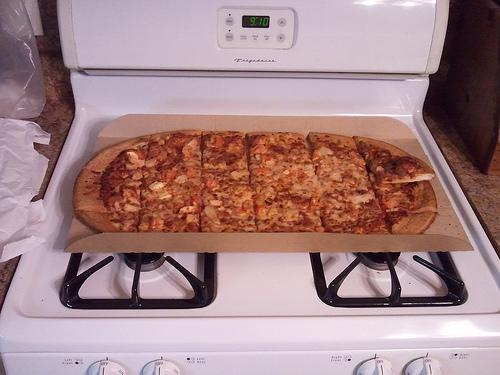Question: how many gas knobs are there?
Choices:
A. Five.
B. Four.
C. Six.
D. Seven.
Answer with the letter. Answer: B Question: what shape is the pizza?
Choices:
A. Square.
B. Oval.
C. Rectangle.
D. Circle.
Answer with the letter. Answer: B Question: how many buttons are on the oven?
Choices:
A. Four.
B. Nine.
C. Seven.
D. Ten.
Answer with the letter. Answer: C 